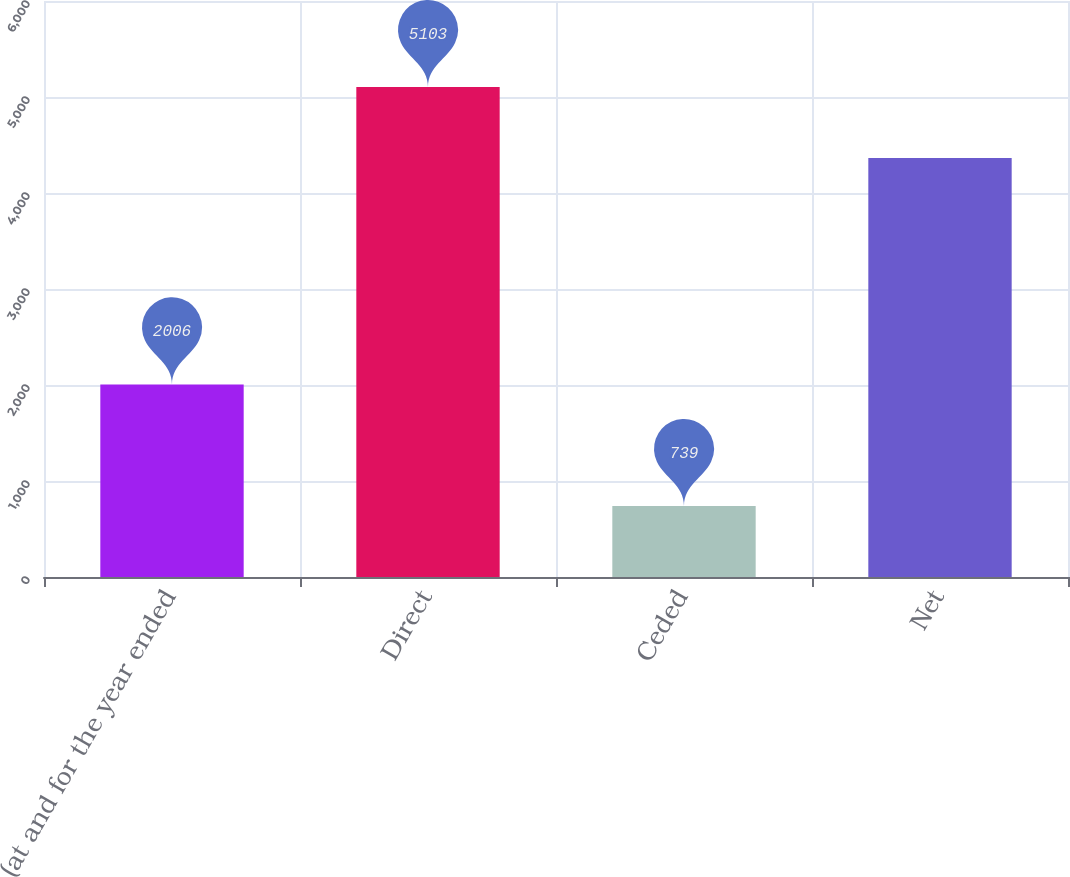Convert chart. <chart><loc_0><loc_0><loc_500><loc_500><bar_chart><fcel>(at and for the year ended<fcel>Direct<fcel>Ceded<fcel>Net<nl><fcel>2006<fcel>5103<fcel>739<fcel>4364<nl></chart> 